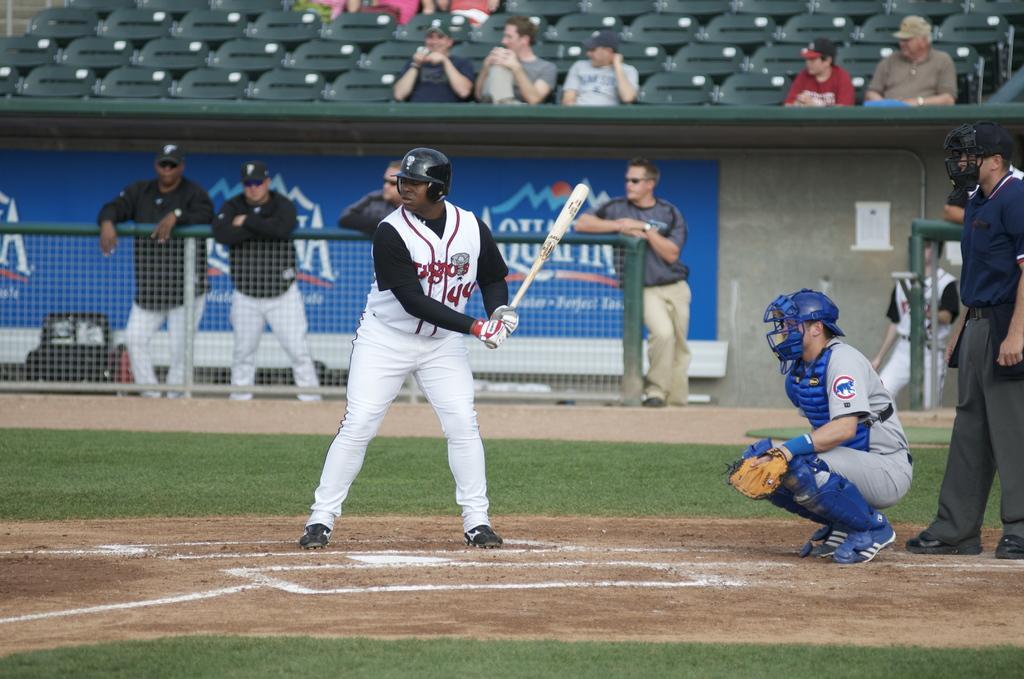In one or two sentences, can you explain what this image depicts? The man in white T-shirt who is wearing a black helmet is holding a baseball bat in his hand. I think he is playing a baseball. Behind him, the man in grey T-shirt who is wearing a blue helmet is in squad position. Behind him, we see a fence and people standing beside that. In the background, we see people sitting on the chairs. At the bottom of the picture, we see the grass and this picture is clicked on the baseball ground. 